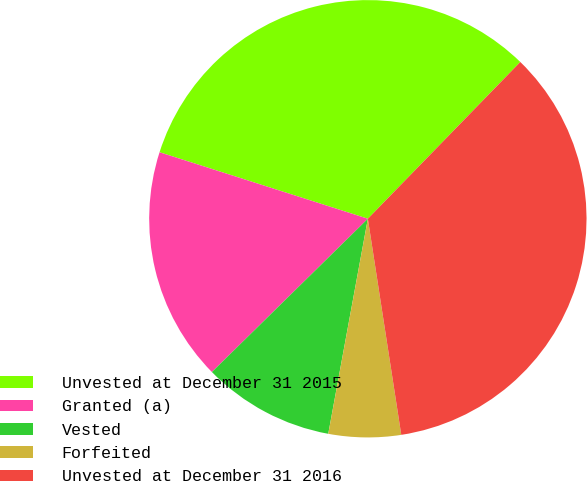Convert chart to OTSL. <chart><loc_0><loc_0><loc_500><loc_500><pie_chart><fcel>Unvested at December 31 2015<fcel>Granted (a)<fcel>Vested<fcel>Forfeited<fcel>Unvested at December 31 2016<nl><fcel>32.36%<fcel>17.28%<fcel>9.74%<fcel>5.34%<fcel>35.28%<nl></chart> 